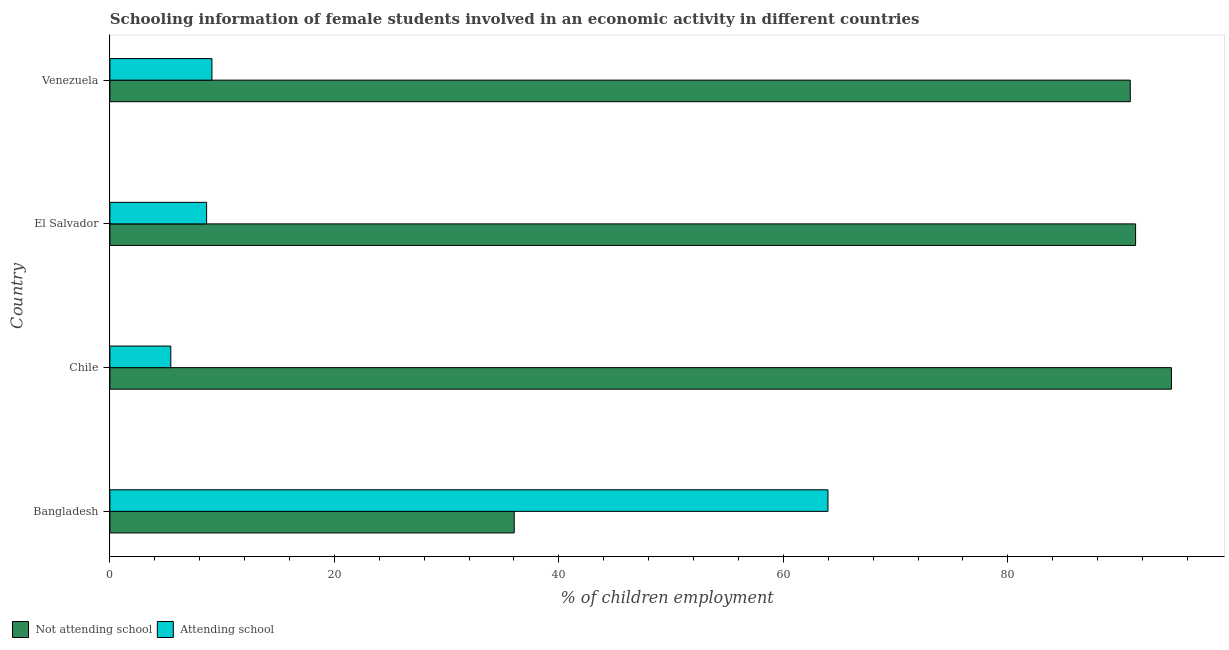How many different coloured bars are there?
Provide a succinct answer. 2. How many groups of bars are there?
Ensure brevity in your answer.  4. Are the number of bars on each tick of the Y-axis equal?
Provide a short and direct response. Yes. How many bars are there on the 3rd tick from the bottom?
Make the answer very short. 2. What is the label of the 1st group of bars from the top?
Keep it short and to the point. Venezuela. What is the percentage of employed females who are attending school in El Salvador?
Your answer should be very brief. 8.62. Across all countries, what is the maximum percentage of employed females who are attending school?
Your answer should be compact. 63.98. Across all countries, what is the minimum percentage of employed females who are attending school?
Provide a succinct answer. 5.43. In which country was the percentage of employed females who are attending school maximum?
Give a very brief answer. Bangladesh. What is the total percentage of employed females who are attending school in the graph?
Provide a short and direct response. 87.11. What is the difference between the percentage of employed females who are attending school in Chile and that in El Salvador?
Your answer should be very brief. -3.19. What is the difference between the percentage of employed females who are attending school in Bangladesh and the percentage of employed females who are not attending school in Chile?
Provide a short and direct response. -30.6. What is the average percentage of employed females who are attending school per country?
Give a very brief answer. 21.78. What is the difference between the percentage of employed females who are not attending school and percentage of employed females who are attending school in Venezuela?
Ensure brevity in your answer.  81.82. In how many countries, is the percentage of employed females who are attending school greater than 80 %?
Make the answer very short. 0. What is the ratio of the percentage of employed females who are not attending school in Chile to that in Venezuela?
Give a very brief answer. 1.04. Is the percentage of employed females who are attending school in El Salvador less than that in Venezuela?
Your answer should be compact. Yes. Is the difference between the percentage of employed females who are not attending school in El Salvador and Venezuela greater than the difference between the percentage of employed females who are attending school in El Salvador and Venezuela?
Your answer should be very brief. Yes. What is the difference between the highest and the second highest percentage of employed females who are attending school?
Your answer should be very brief. 54.88. What is the difference between the highest and the lowest percentage of employed females who are not attending school?
Make the answer very short. 58.55. What does the 2nd bar from the top in Chile represents?
Ensure brevity in your answer.  Not attending school. What does the 1st bar from the bottom in El Salvador represents?
Keep it short and to the point. Not attending school. How many bars are there?
Provide a succinct answer. 8. Are all the bars in the graph horizontal?
Ensure brevity in your answer.  Yes. How many countries are there in the graph?
Your answer should be very brief. 4. What is the difference between two consecutive major ticks on the X-axis?
Ensure brevity in your answer.  20. Does the graph contain any zero values?
Your answer should be compact. No. What is the title of the graph?
Your response must be concise. Schooling information of female students involved in an economic activity in different countries. Does "Travel services" appear as one of the legend labels in the graph?
Ensure brevity in your answer.  No. What is the label or title of the X-axis?
Provide a short and direct response. % of children employment. What is the label or title of the Y-axis?
Your answer should be compact. Country. What is the % of children employment in Not attending school in Bangladesh?
Make the answer very short. 36.02. What is the % of children employment in Attending school in Bangladesh?
Ensure brevity in your answer.  63.98. What is the % of children employment in Not attending school in Chile?
Give a very brief answer. 94.57. What is the % of children employment of Attending school in Chile?
Provide a succinct answer. 5.43. What is the % of children employment of Not attending school in El Salvador?
Ensure brevity in your answer.  91.38. What is the % of children employment in Attending school in El Salvador?
Your response must be concise. 8.62. What is the % of children employment of Not attending school in Venezuela?
Make the answer very short. 90.91. What is the % of children employment of Attending school in Venezuela?
Provide a short and direct response. 9.09. Across all countries, what is the maximum % of children employment in Not attending school?
Ensure brevity in your answer.  94.57. Across all countries, what is the maximum % of children employment in Attending school?
Provide a succinct answer. 63.98. Across all countries, what is the minimum % of children employment of Not attending school?
Offer a terse response. 36.02. Across all countries, what is the minimum % of children employment in Attending school?
Make the answer very short. 5.43. What is the total % of children employment of Not attending school in the graph?
Offer a terse response. 312.89. What is the total % of children employment of Attending school in the graph?
Give a very brief answer. 87.11. What is the difference between the % of children employment in Not attending school in Bangladesh and that in Chile?
Your response must be concise. -58.55. What is the difference between the % of children employment of Attending school in Bangladesh and that in Chile?
Offer a very short reply. 58.55. What is the difference between the % of children employment of Not attending school in Bangladesh and that in El Salvador?
Ensure brevity in your answer.  -55.36. What is the difference between the % of children employment of Attending school in Bangladesh and that in El Salvador?
Offer a very short reply. 55.36. What is the difference between the % of children employment of Not attending school in Bangladesh and that in Venezuela?
Give a very brief answer. -54.88. What is the difference between the % of children employment in Attending school in Bangladesh and that in Venezuela?
Provide a short and direct response. 54.88. What is the difference between the % of children employment of Not attending school in Chile and that in El Salvador?
Offer a terse response. 3.19. What is the difference between the % of children employment of Attending school in Chile and that in El Salvador?
Your answer should be very brief. -3.19. What is the difference between the % of children employment of Not attending school in Chile and that in Venezuela?
Ensure brevity in your answer.  3.67. What is the difference between the % of children employment of Attending school in Chile and that in Venezuela?
Your answer should be very brief. -3.67. What is the difference between the % of children employment in Not attending school in El Salvador and that in Venezuela?
Your answer should be very brief. 0.47. What is the difference between the % of children employment of Attending school in El Salvador and that in Venezuela?
Give a very brief answer. -0.47. What is the difference between the % of children employment of Not attending school in Bangladesh and the % of children employment of Attending school in Chile?
Keep it short and to the point. 30.6. What is the difference between the % of children employment in Not attending school in Bangladesh and the % of children employment in Attending school in El Salvador?
Your answer should be compact. 27.41. What is the difference between the % of children employment in Not attending school in Bangladesh and the % of children employment in Attending school in Venezuela?
Offer a very short reply. 26.93. What is the difference between the % of children employment in Not attending school in Chile and the % of children employment in Attending school in El Salvador?
Offer a very short reply. 85.96. What is the difference between the % of children employment of Not attending school in Chile and the % of children employment of Attending school in Venezuela?
Provide a succinct answer. 85.48. What is the difference between the % of children employment in Not attending school in El Salvador and the % of children employment in Attending school in Venezuela?
Provide a short and direct response. 82.29. What is the average % of children employment in Not attending school per country?
Your answer should be compact. 78.22. What is the average % of children employment in Attending school per country?
Your response must be concise. 21.78. What is the difference between the % of children employment in Not attending school and % of children employment in Attending school in Bangladesh?
Keep it short and to the point. -27.95. What is the difference between the % of children employment of Not attending school and % of children employment of Attending school in Chile?
Ensure brevity in your answer.  89.15. What is the difference between the % of children employment of Not attending school and % of children employment of Attending school in El Salvador?
Your response must be concise. 82.77. What is the difference between the % of children employment of Not attending school and % of children employment of Attending school in Venezuela?
Ensure brevity in your answer.  81.82. What is the ratio of the % of children employment of Not attending school in Bangladesh to that in Chile?
Ensure brevity in your answer.  0.38. What is the ratio of the % of children employment in Attending school in Bangladesh to that in Chile?
Your answer should be very brief. 11.79. What is the ratio of the % of children employment in Not attending school in Bangladesh to that in El Salvador?
Provide a succinct answer. 0.39. What is the ratio of the % of children employment in Attending school in Bangladesh to that in El Salvador?
Your response must be concise. 7.42. What is the ratio of the % of children employment of Not attending school in Bangladesh to that in Venezuela?
Your response must be concise. 0.4. What is the ratio of the % of children employment of Attending school in Bangladesh to that in Venezuela?
Provide a short and direct response. 7.04. What is the ratio of the % of children employment in Not attending school in Chile to that in El Salvador?
Give a very brief answer. 1.03. What is the ratio of the % of children employment in Attending school in Chile to that in El Salvador?
Offer a very short reply. 0.63. What is the ratio of the % of children employment of Not attending school in Chile to that in Venezuela?
Keep it short and to the point. 1.04. What is the ratio of the % of children employment of Attending school in Chile to that in Venezuela?
Offer a terse response. 0.6. What is the ratio of the % of children employment of Attending school in El Salvador to that in Venezuela?
Your response must be concise. 0.95. What is the difference between the highest and the second highest % of children employment of Not attending school?
Your answer should be compact. 3.19. What is the difference between the highest and the second highest % of children employment of Attending school?
Your answer should be compact. 54.88. What is the difference between the highest and the lowest % of children employment of Not attending school?
Provide a succinct answer. 58.55. What is the difference between the highest and the lowest % of children employment in Attending school?
Your answer should be very brief. 58.55. 